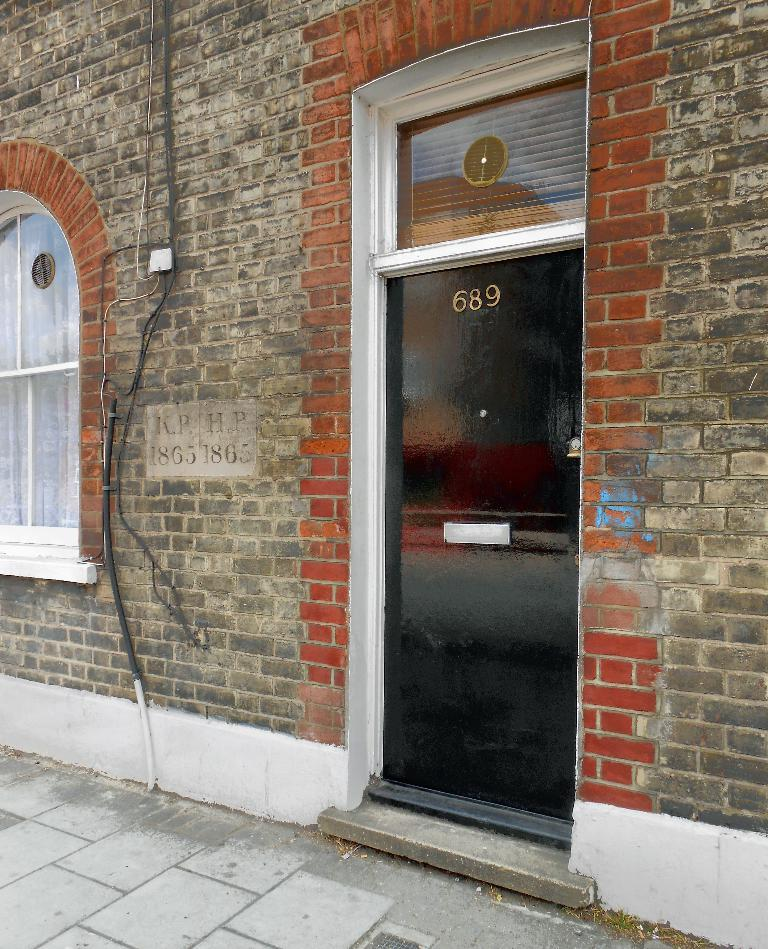What type of structure is present in the image? There is a building in the image. What material is the building made of? The building is made up of bricks. Are there any openings in the building? Yes, there is a window and a glass door in the building. What is connected to the building? There are wires connected to the building. What can be seen below the building? The ground is visible in the image. Can you see any cherries growing on the building in the image? There are no cherries present in the image, as it features a brick building with a window, a glass door, and wires connected to it. 